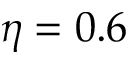<formula> <loc_0><loc_0><loc_500><loc_500>\eta = 0 . 6</formula> 